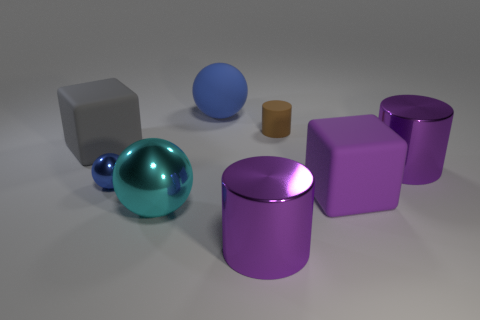Which objects in the image have reflective surfaces? The sphere and the cylinder appear to have reflective surfaces, as indicated by the visible highlights and reflections on them. 